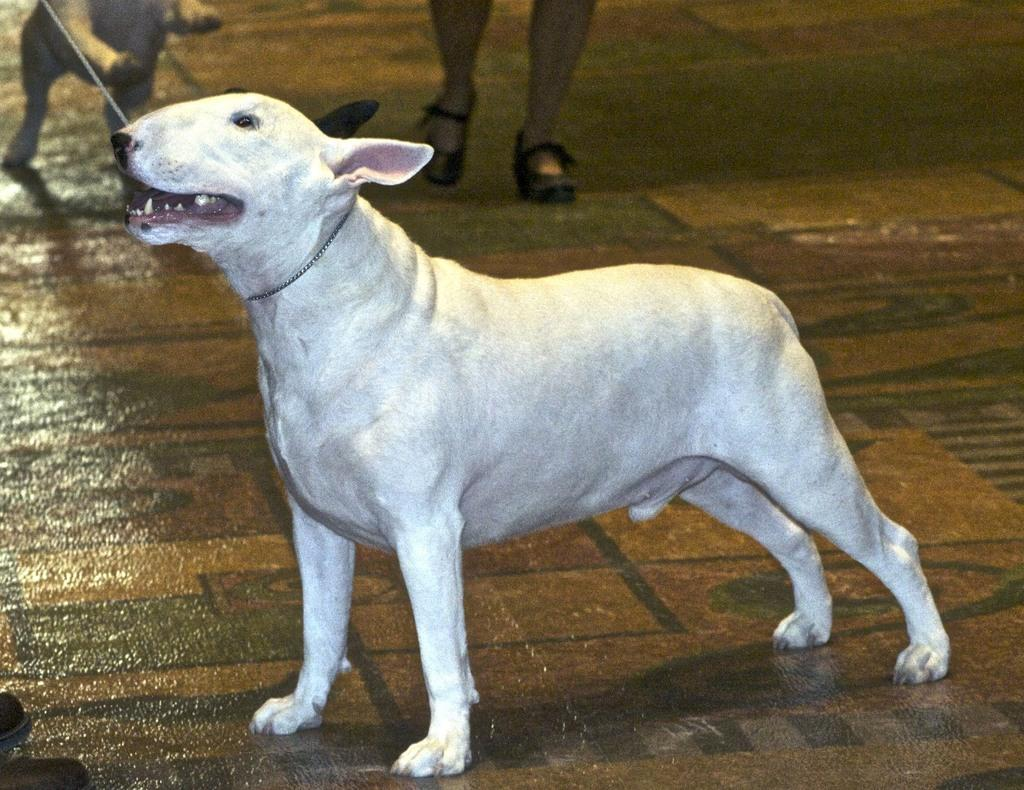What type of animal can be seen in the image? There is a dog in the image. Are there any other dogs in the image? Yes, there is another dog on the side in the image. Can you describe the presence of humans in the image? Human legs are visible in the image. What is the color of one of the dogs in the image? One of the dogs is white in color. What type of square object is being used in the war depicted in the image? There is no war or square object present in the image; it features two dogs and human legs. 